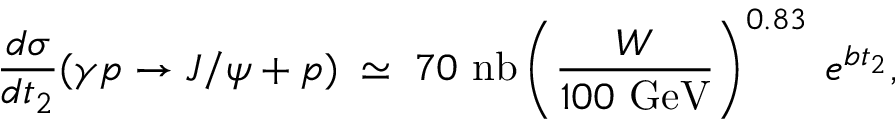<formula> <loc_0><loc_0><loc_500><loc_500>\frac { d \sigma } { d t _ { 2 } } ( \gamma p \rightarrow J / \psi + p ) \, \simeq \, 7 0 n b \left ( \frac { W } { 1 0 0 G e V } \right ) ^ { 0 . 8 3 } \, e ^ { b t _ { 2 } } ,</formula> 